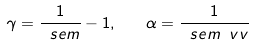Convert formula to latex. <formula><loc_0><loc_0><loc_500><loc_500>\gamma = \frac { 1 } { \ s e m } - 1 , \quad \alpha = \frac { 1 } { \ s e m \ v v }</formula> 